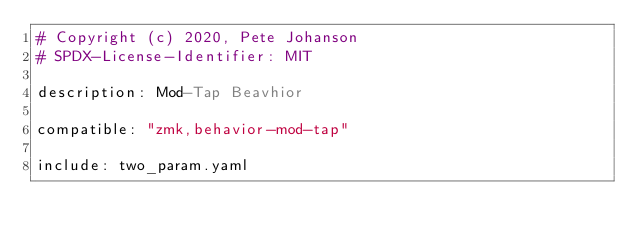<code> <loc_0><loc_0><loc_500><loc_500><_YAML_># Copyright (c) 2020, Pete Johanson
# SPDX-License-Identifier: MIT

description: Mod-Tap Beavhior

compatible: "zmk,behavior-mod-tap"

include: two_param.yaml
</code> 